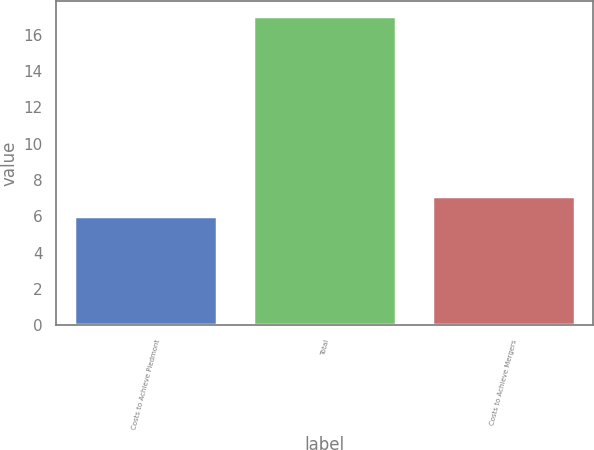Convert chart to OTSL. <chart><loc_0><loc_0><loc_500><loc_500><bar_chart><fcel>Costs to Achieve Piedmont<fcel>Total<fcel>Costs to Achieve Mergers<nl><fcel>6<fcel>17<fcel>7.1<nl></chart> 